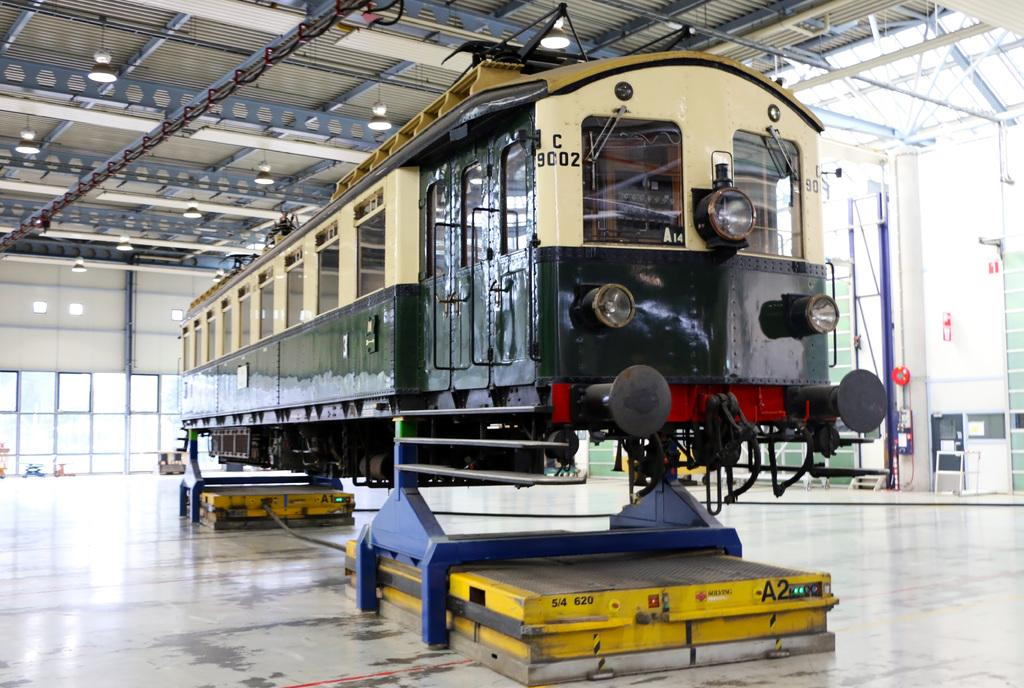What is the main subject of the image? The main subject of the image is a train. How is the train positioned in the image? The train is on a metal stand. Where is the metal stand placed? The metal stand is placed on the floor. What other objects can be seen in the image? There are poles, windows, a roof with ceiling lights, and metal rods in the image. What type of organization is responsible for the train in the image? The image does not provide information about the organization responsible for the train. Is there a scarf visible on the train in the image? There is no scarf present on the train in the image. 